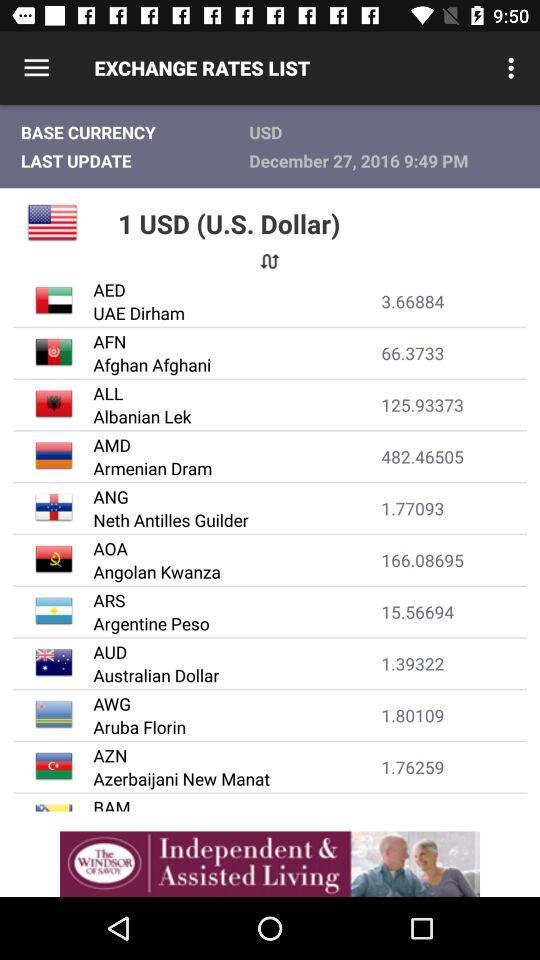Which country's currency value is equivalent to 1.39322 for 1 USD? For 1 USD, the currency value of Australia is equivalent to 1.39322. 